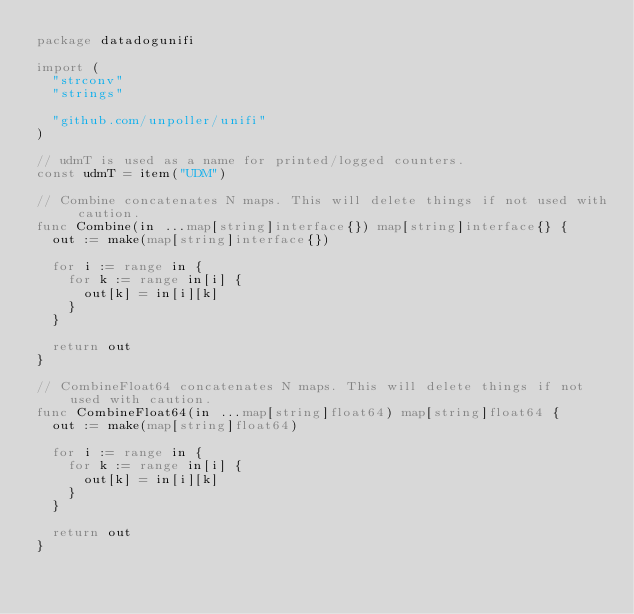Convert code to text. <code><loc_0><loc_0><loc_500><loc_500><_Go_>package datadogunifi

import (
	"strconv"
	"strings"

	"github.com/unpoller/unifi"
)

// udmT is used as a name for printed/logged counters.
const udmT = item("UDM")

// Combine concatenates N maps. This will delete things if not used with caution.
func Combine(in ...map[string]interface{}) map[string]interface{} {
	out := make(map[string]interface{})

	for i := range in {
		for k := range in[i] {
			out[k] = in[i][k]
		}
	}

	return out
}

// CombineFloat64 concatenates N maps. This will delete things if not used with caution.
func CombineFloat64(in ...map[string]float64) map[string]float64 {
	out := make(map[string]float64)

	for i := range in {
		for k := range in[i] {
			out[k] = in[i][k]
		}
	}

	return out
}
</code> 